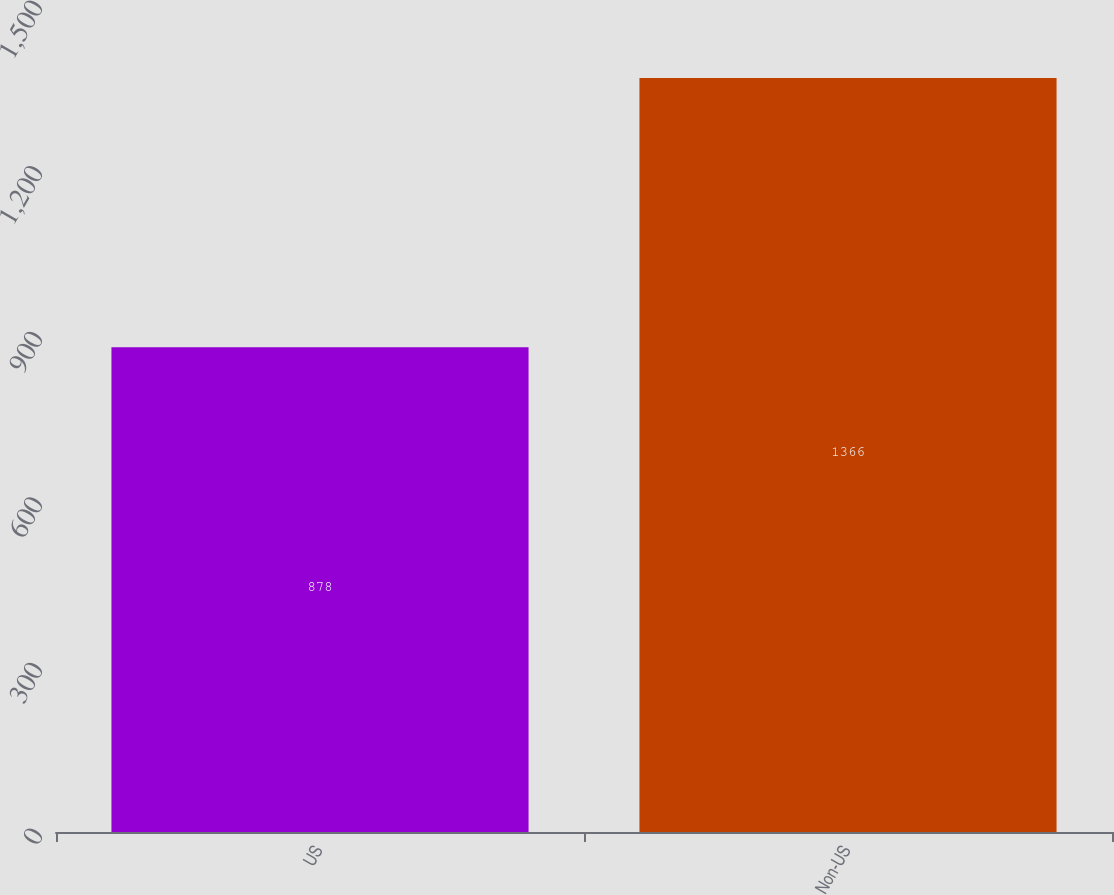<chart> <loc_0><loc_0><loc_500><loc_500><bar_chart><fcel>US<fcel>Non-US<nl><fcel>878<fcel>1366<nl></chart> 